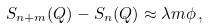Convert formula to latex. <formula><loc_0><loc_0><loc_500><loc_500>S _ { n + m } ( Q ) - S _ { n } ( Q ) \approx \lambda m \phi \, ,</formula> 